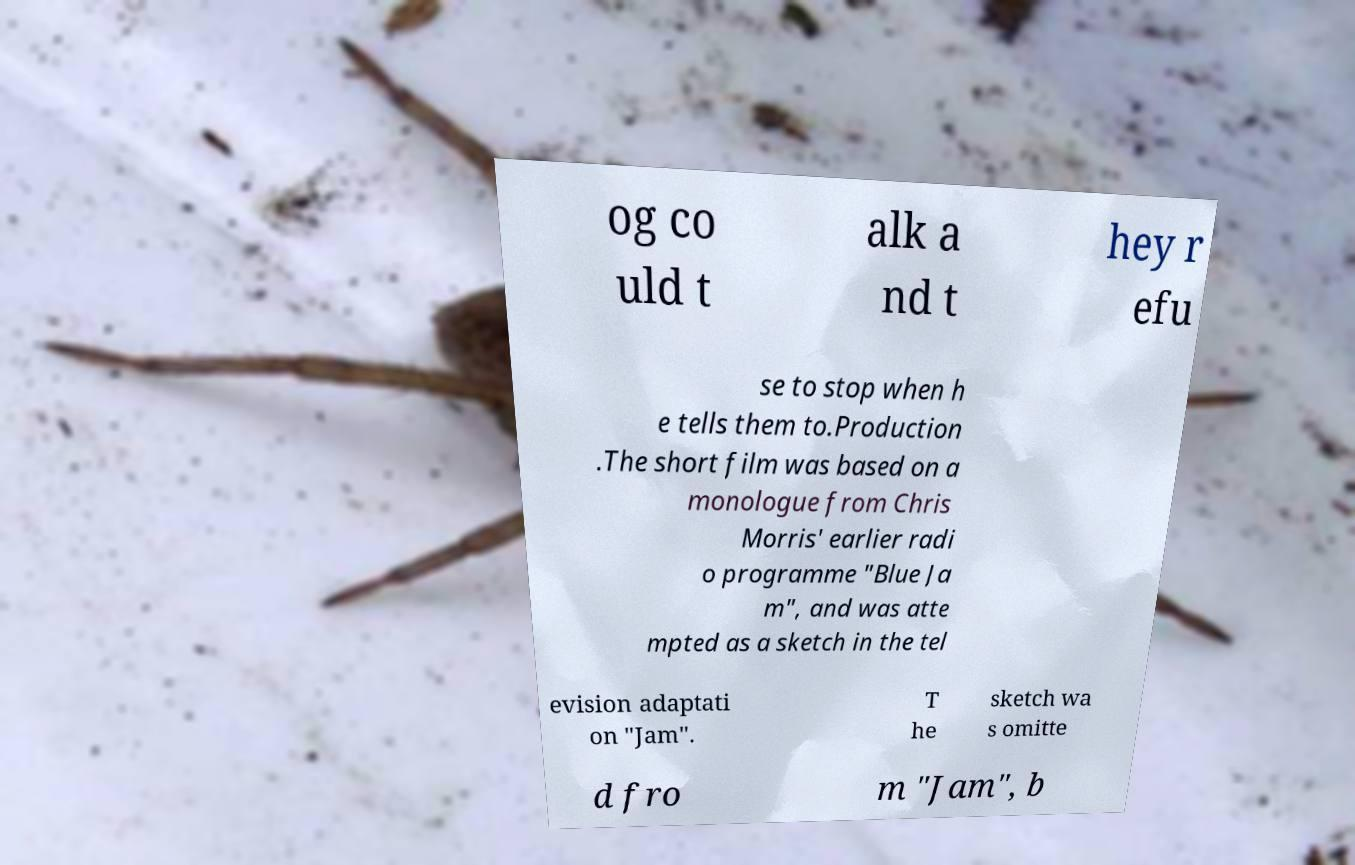Please read and relay the text visible in this image. What does it say? og co uld t alk a nd t hey r efu se to stop when h e tells them to.Production .The short film was based on a monologue from Chris Morris' earlier radi o programme "Blue Ja m", and was atte mpted as a sketch in the tel evision adaptati on "Jam". T he sketch wa s omitte d fro m "Jam", b 